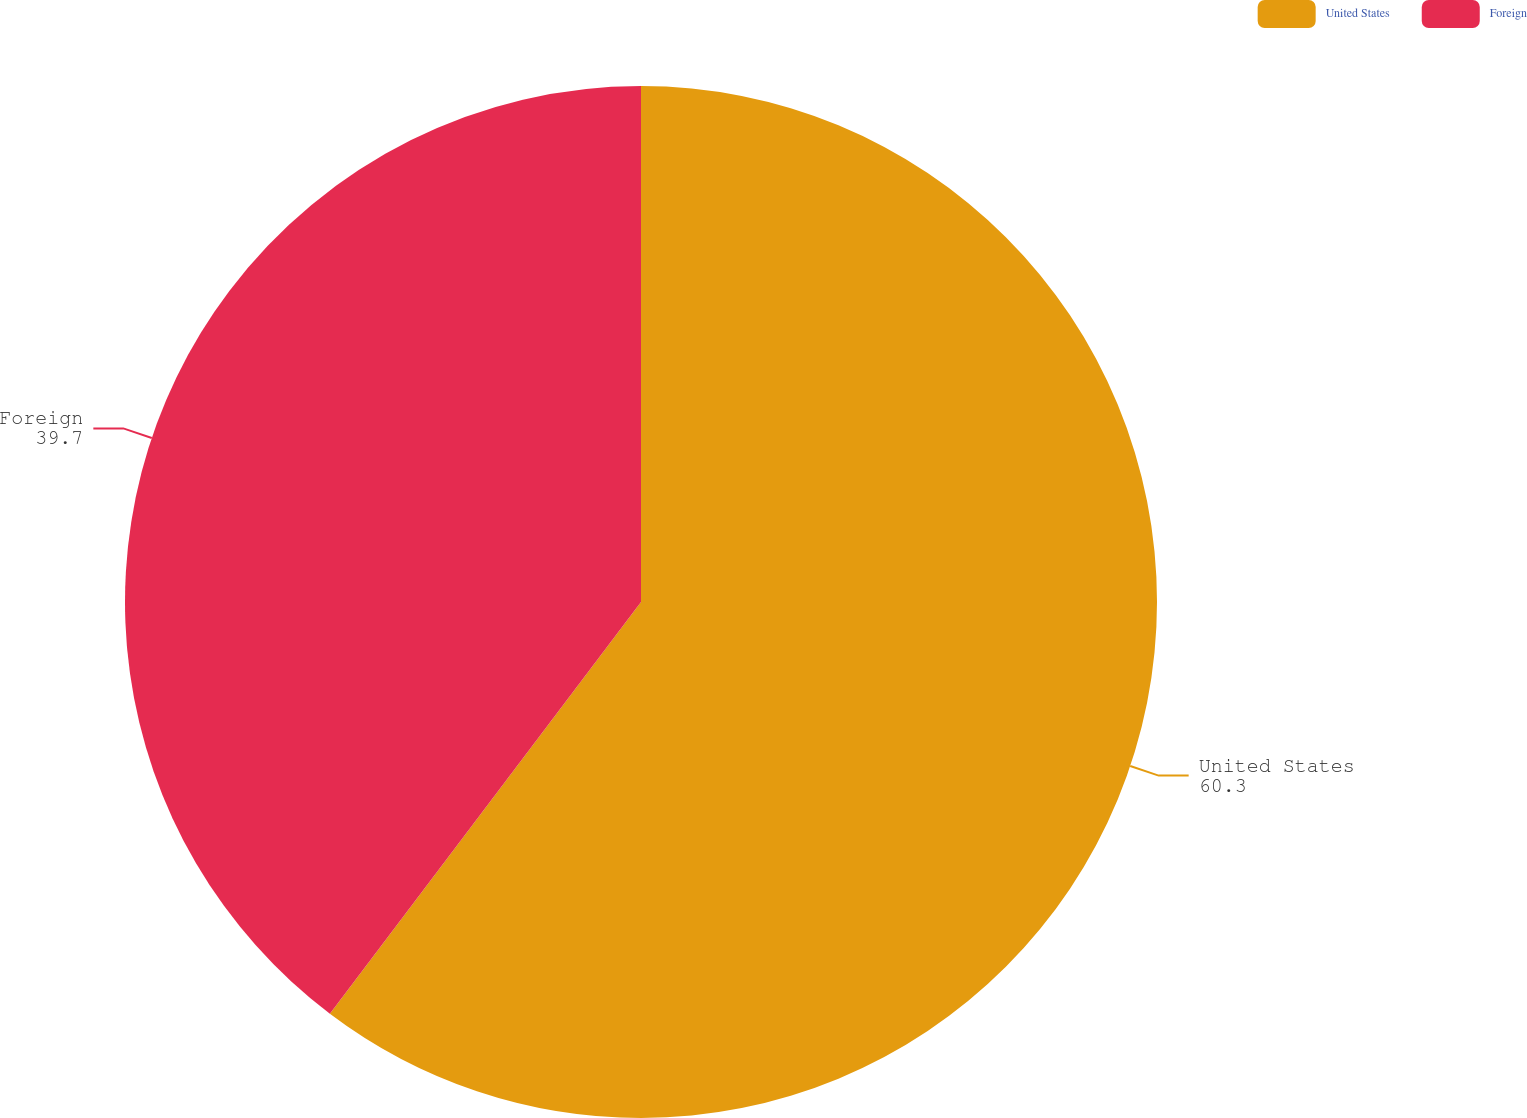Convert chart. <chart><loc_0><loc_0><loc_500><loc_500><pie_chart><fcel>United States<fcel>Foreign<nl><fcel>60.3%<fcel>39.7%<nl></chart> 